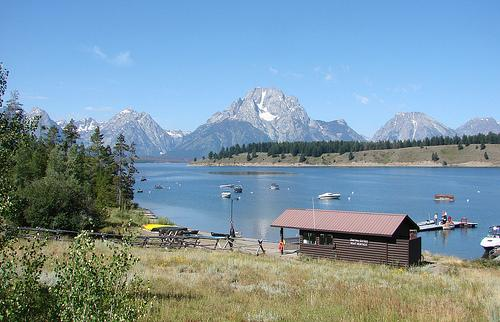Count the number of boats present in the image. There are three boats in the image. What is the condition of the sky in this image? The sky is clear and blue. Mention the type of structure on the lake and describe its color. There is a store on the lake, and it is brown in color. Are there any patches of forest or trees in this image? If yes, describe their colors. Yes, there are trees in the foreground and background shorelines. The leaves are short and green. What is the color of the grass near the shoreline? The grass near the shoreline is yellow. Describe one noteworthy artificial construction found in the image. There is a metal gate, possibly located near the shoreline. Enumerate what objects can be found on the lake. On the lake, there are a boat, calm water, and the reflection of the clear blue sky. Are there any majestic natural elements in the image? If so, describe them. Yes, there are majestic mountains in the background, with some of them having snow on their peaks. Can you find any human activity happening in this image? If yes, describe it. Yes, there is a person standing on the pier, possibly looking at the calm lake. How would you describe the water in the lake? The lake water is calm and blue. Are the clouds in the sky a bright green shade? The sky is described as clear and blue, so no colors related to clouds are mentioned and certainly not green. Are there red boats floating on the lake? No, it's not mentioned in the image. Is the grass near the shoreline bright pink? The actual color of the grass in the image is yellow, not bright pink. Is there a tall purple building by the lake? The building by the lake is described as brown, not purple, and its size is not mentioned as tall. 